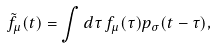<formula> <loc_0><loc_0><loc_500><loc_500>\tilde { f } _ { \mu } ( t ) = \int d \tau \, f _ { \mu } ( \tau ) p _ { \sigma } ( t - \tau ) ,</formula> 